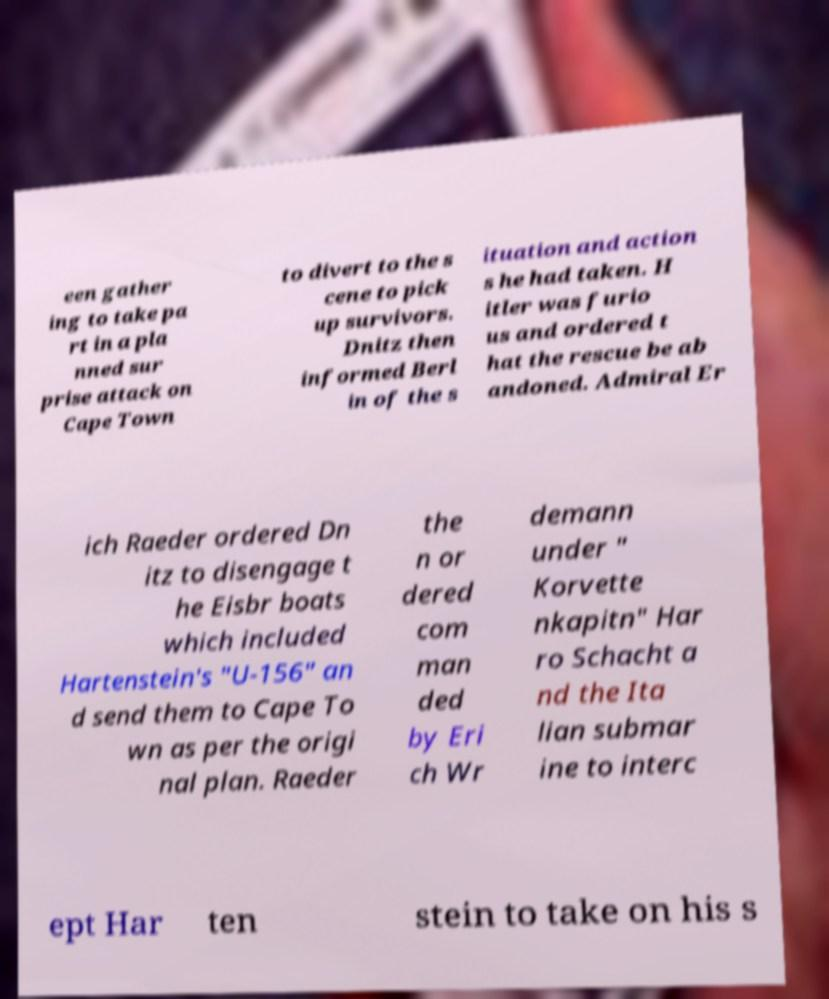Please read and relay the text visible in this image. What does it say? een gather ing to take pa rt in a pla nned sur prise attack on Cape Town to divert to the s cene to pick up survivors. Dnitz then informed Berl in of the s ituation and action s he had taken. H itler was furio us and ordered t hat the rescue be ab andoned. Admiral Er ich Raeder ordered Dn itz to disengage t he Eisbr boats which included Hartenstein's "U-156" an d send them to Cape To wn as per the origi nal plan. Raeder the n or dered com man ded by Eri ch Wr demann under " Korvette nkapitn" Har ro Schacht a nd the Ita lian submar ine to interc ept Har ten stein to take on his s 